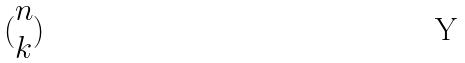<formula> <loc_0><loc_0><loc_500><loc_500>( \begin{matrix} n \\ k \end{matrix} )</formula> 